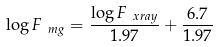Convert formula to latex. <formula><loc_0><loc_0><loc_500><loc_500>\log { F _ { \ m g } } = \frac { \log { F _ { \ x r a y } } } { 1 . 9 7 } + \frac { 6 . 7 } { 1 . 9 7 }</formula> 